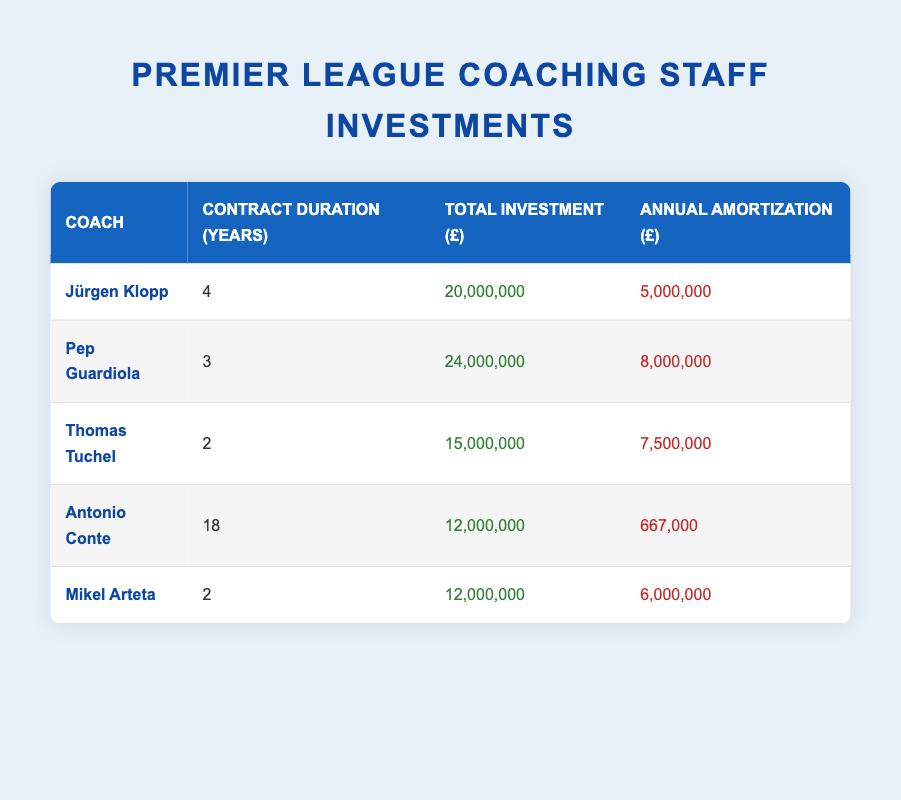What is the total investment made in coaching staff? To find the total investment, sum up the total investments for each coach: 20,000,000 + 24,000,000 + 15,000,000 + 12,000,000 + 12,000,000 = 83,000,000.
Answer: 83,000,000 Which coach has the highest annual amortization? Looking at the annual amortization amounts, Pep Guardiola has the highest at 8,000,000, as listed in the table.
Answer: Pep Guardiola What is the average contract duration of the coaching staff? To calculate the average contract duration, sum all the contract durations: 4 + 3 + 2 + 18 + 2 = 29. Then, divide by the number of coaches (5), which gives 29 / 5 = 5.8 years.
Answer: 5.8 years Is Mikel Arteta's total investment higher than that of Antonio Conte? Mikel Arteta's total investment is 12,000,000, while Antonio Conte's is also 12,000,000. Since they are equal, the answer is no.
Answer: No What is the total annual amortization of all coaches combined? Sum the annual amortization values: 5,000,000 + 8,000,000 + 7,500,000 + 667,000 + 6,000,000 = 27,167,000.
Answer: 27,167,000 How much more was invested in Pep Guardiola compared to Mikel Arteta? Pep Guardiola's investment is 24,000,000 and Mikel Arteta's is 12,000,000. The difference is 24,000,000 - 12,000,000 = 12,000,000.
Answer: 12,000,000 What percentage of the total investment does Jürgen Klopp's investment represent? Jürgen Klopp's investment is 20,000,000. To find the percentage, calculate (20,000,000 / 83,000,000) * 100, which is approximately 24.1%.
Answer: 24.1% Which coach has the shortest contract duration, and what is it? The shortest contract duration in the table belongs to both Thomas Tuchel and Mikel Arteta, both with 2 years.
Answer: Thomas Tuchel and Mikel Arteta, 2 years If we average the annual amortization, how much is it? The total annual amortization calculated is 27,167,000. Dividing this by the number of coaches (5), gives an average of 27,167,000 / 5 = 5,433,400.
Answer: 5,433,400 